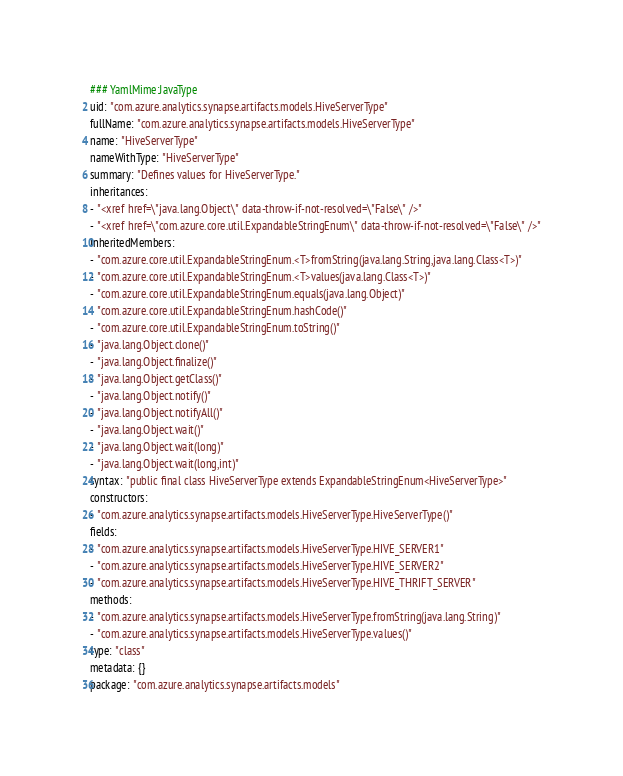Convert code to text. <code><loc_0><loc_0><loc_500><loc_500><_YAML_>### YamlMime:JavaType
uid: "com.azure.analytics.synapse.artifacts.models.HiveServerType"
fullName: "com.azure.analytics.synapse.artifacts.models.HiveServerType"
name: "HiveServerType"
nameWithType: "HiveServerType"
summary: "Defines values for HiveServerType."
inheritances:
- "<xref href=\"java.lang.Object\" data-throw-if-not-resolved=\"False\" />"
- "<xref href=\"com.azure.core.util.ExpandableStringEnum\" data-throw-if-not-resolved=\"False\" />"
inheritedMembers:
- "com.azure.core.util.ExpandableStringEnum.<T>fromString(java.lang.String,java.lang.Class<T>)"
- "com.azure.core.util.ExpandableStringEnum.<T>values(java.lang.Class<T>)"
- "com.azure.core.util.ExpandableStringEnum.equals(java.lang.Object)"
- "com.azure.core.util.ExpandableStringEnum.hashCode()"
- "com.azure.core.util.ExpandableStringEnum.toString()"
- "java.lang.Object.clone()"
- "java.lang.Object.finalize()"
- "java.lang.Object.getClass()"
- "java.lang.Object.notify()"
- "java.lang.Object.notifyAll()"
- "java.lang.Object.wait()"
- "java.lang.Object.wait(long)"
- "java.lang.Object.wait(long,int)"
syntax: "public final class HiveServerType extends ExpandableStringEnum<HiveServerType>"
constructors:
- "com.azure.analytics.synapse.artifacts.models.HiveServerType.HiveServerType()"
fields:
- "com.azure.analytics.synapse.artifacts.models.HiveServerType.HIVE_SERVER1"
- "com.azure.analytics.synapse.artifacts.models.HiveServerType.HIVE_SERVER2"
- "com.azure.analytics.synapse.artifacts.models.HiveServerType.HIVE_THRIFT_SERVER"
methods:
- "com.azure.analytics.synapse.artifacts.models.HiveServerType.fromString(java.lang.String)"
- "com.azure.analytics.synapse.artifacts.models.HiveServerType.values()"
type: "class"
metadata: {}
package: "com.azure.analytics.synapse.artifacts.models"</code> 